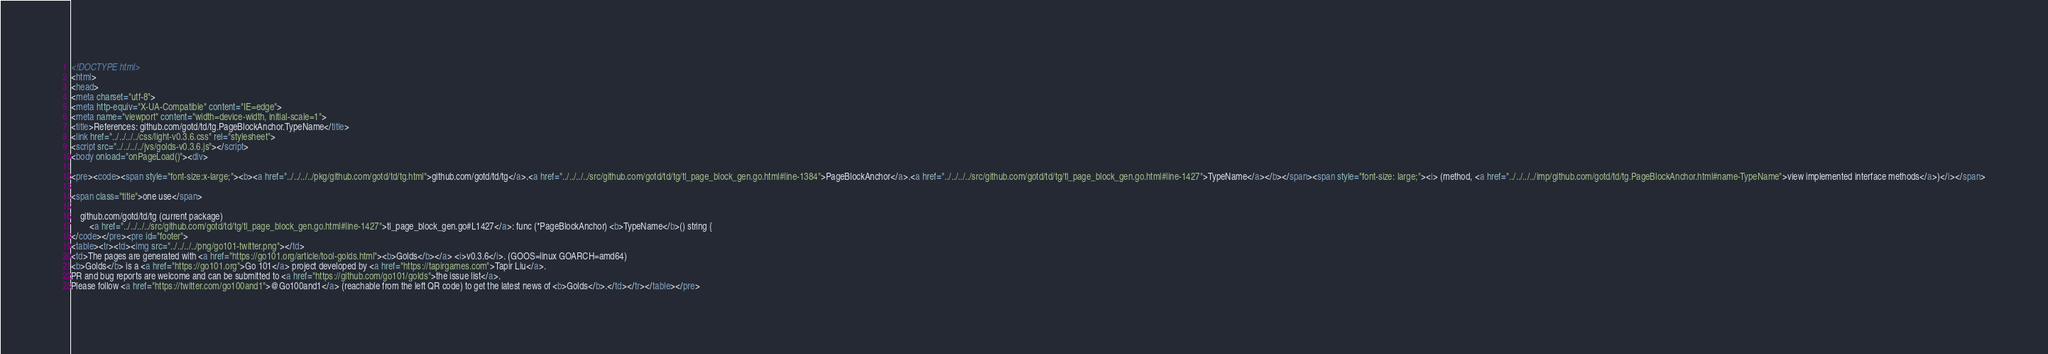Convert code to text. <code><loc_0><loc_0><loc_500><loc_500><_HTML_><!DOCTYPE html>
<html>
<head>
<meta charset="utf-8">
<meta http-equiv="X-UA-Compatible" content="IE=edge">
<meta name="viewport" content="width=device-width, initial-scale=1">
<title>References: github.com/gotd/td/tg.PageBlockAnchor.TypeName</title>
<link href="../../../../css/light-v0.3.6.css" rel="stylesheet">
<script src="../../../../jvs/golds-v0.3.6.js"></script>
<body onload="onPageLoad()"><div>

<pre><code><span style="font-size:x-large;"><b><a href="../../../../pkg/github.com/gotd/td/tg.html">github.com/gotd/td/tg</a>.<a href="../../../../src/github.com/gotd/td/tg/tl_page_block_gen.go.html#line-1384">PageBlockAnchor</a>.<a href="../../../../src/github.com/gotd/td/tg/tl_page_block_gen.go.html#line-1427">TypeName</a></b></span><span style="font-size: large;"><i> (method, <a href="../../../../imp/github.com/gotd/td/tg.PageBlockAnchor.html#name-TypeName">view implemented interface methods</a>)</i></span>

<span class="title">one use</span>

	github.com/gotd/td/tg (current package)
		<a href="../../../../src/github.com/gotd/td/tg/tl_page_block_gen.go.html#line-1427">tl_page_block_gen.go#L1427</a>: func (*PageBlockAnchor) <b>TypeName</b>() string {
</code></pre><pre id="footer">
<table><tr><td><img src="../../../../png/go101-twitter.png"></td>
<td>The pages are generated with <a href="https://go101.org/article/tool-golds.html"><b>Golds</b></a> <i>v0.3.6</i>. (GOOS=linux GOARCH=amd64)
<b>Golds</b> is a <a href="https://go101.org">Go 101</a> project developed by <a href="https://tapirgames.com">Tapir Liu</a>.
PR and bug reports are welcome and can be submitted to <a href="https://github.com/go101/golds">the issue list</a>.
Please follow <a href="https://twitter.com/go100and1">@Go100and1</a> (reachable from the left QR code) to get the latest news of <b>Golds</b>.</td></tr></table></pre></code> 